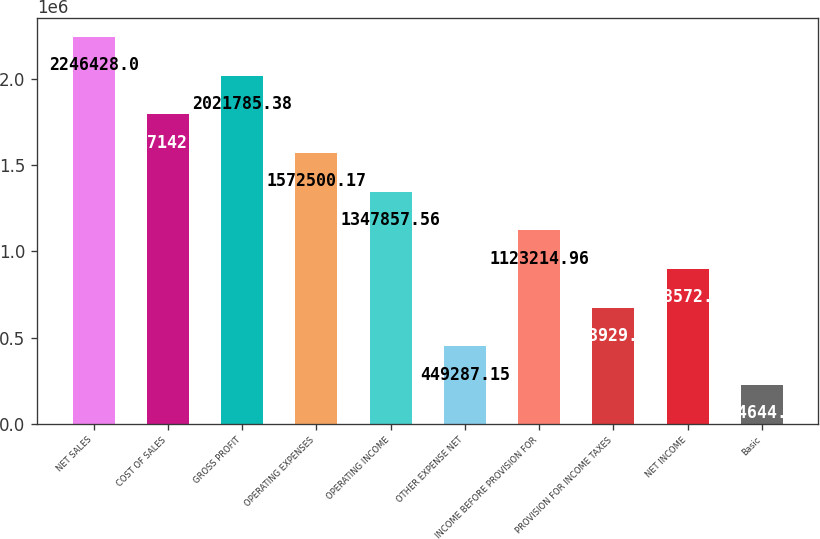<chart> <loc_0><loc_0><loc_500><loc_500><bar_chart><fcel>NET SALES<fcel>COST OF SALES<fcel>GROSS PROFIT<fcel>OPERATING EXPENSES<fcel>OPERATING INCOME<fcel>OTHER EXPENSE NET<fcel>INCOME BEFORE PROVISION FOR<fcel>PROVISION FOR INCOME TAXES<fcel>NET INCOME<fcel>Basic<nl><fcel>2.24643e+06<fcel>1.79714e+06<fcel>2.02179e+06<fcel>1.5725e+06<fcel>1.34786e+06<fcel>449287<fcel>1.12321e+06<fcel>673930<fcel>898572<fcel>224645<nl></chart> 